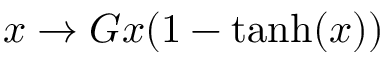Convert formula to latex. <formula><loc_0><loc_0><loc_500><loc_500>x \rightarrow G x ( 1 - t a n h ( x ) )</formula> 